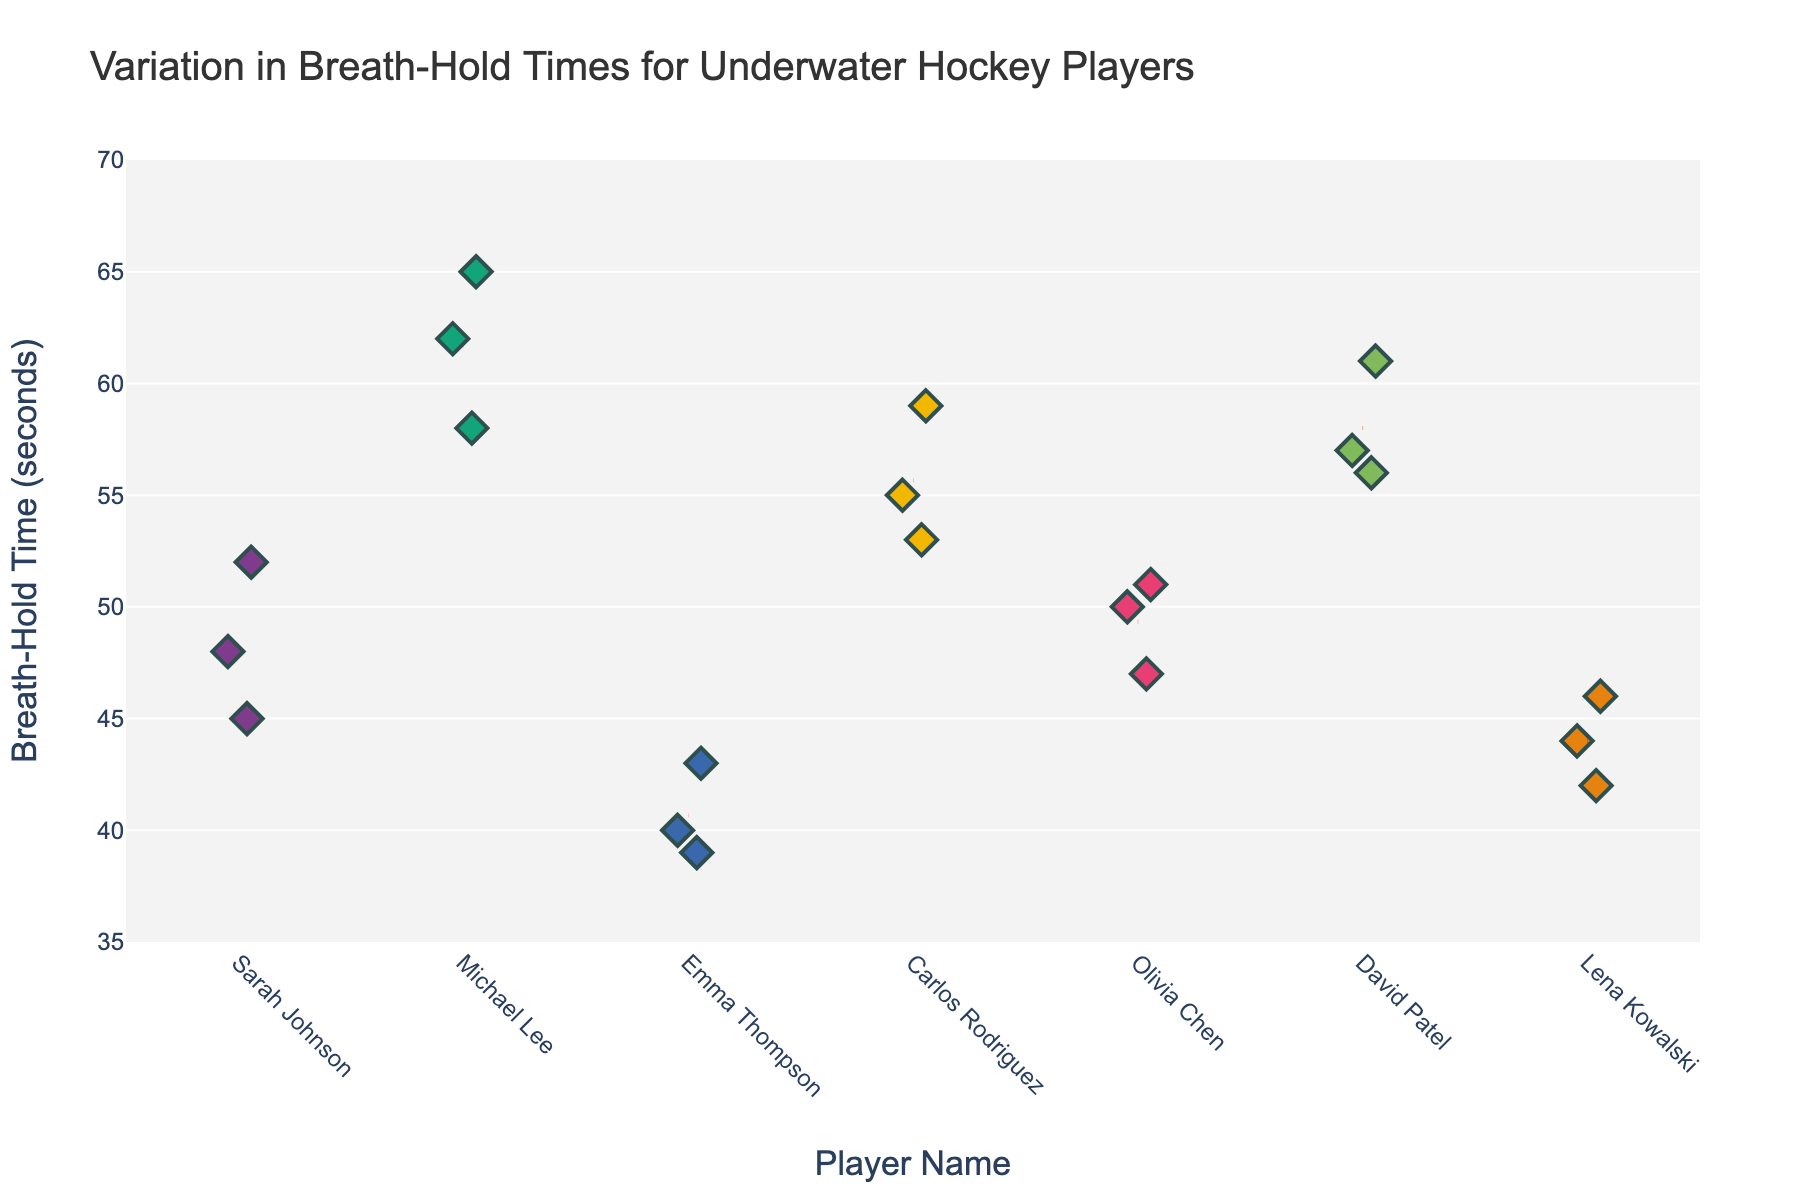What is the title of the figure? The title of the figure is typically displayed at the top of the chart. It provides the viewer with an overview of what the chart represents.
Answer: Variation in Breath-Hold Times for Underwater Hockey Players Which player has the longest breath-hold time? To determine this, look for the highest point in the plot associated with a player.
Answer: Michael Lee What are the y-axis limits in the figure? The y-axis limits are specified by the range of values it covers, from the minimum to the maximum breath-hold times displayed.
Answer: 35 to 70 seconds How many data points does each player have in the figure? Count the number of markers (diamonds) for each player in the plot. Each player should have three data points based on the data provided.
Answer: 3 data points Which player shows the greatest variation in breath-hold times? To find the player with the greatest variation, look for the player whose breath-hold times span the widest range on the y-axis.
Answer: Michael Lee What is the mean breath-hold time for Sarah Johnson? The mean is calculated by averaging Sarah's breath-hold times: (45 + 52 + 48) / 3 = 48.33. Verify this by locating the red dashed mean line associated with her.
Answer: 48.33 seconds Which player has the lowest mean breath-hold time? Compare the red dashed mean lines for each player; the player with the lowest positioned mean line has the lowest mean breath-hold time.
Answer: Emma Thompson How does Carlos Rodriguez's breath-hold times compare to David Patel's? Compare the positions of the markers for both players. Carlos Rodriguez’s times range between 53 and 59, while David Patel’s range between 56 and 61.
Answer: Carlos Rodriguez has slightly lower breath-hold times overall Which player has the most consistent breath-hold times? Consistency can be inferred from the tight clustering of data points for a player. Look for the player whose breath-hold times lie closest together.
Answer: Olivia Chen What are the breath-hold time ranges for Lena Kowalski? Lena’s breath-hold times range from the minimum to the maximum value among her data points.
Answer: 42 to 46 seconds 